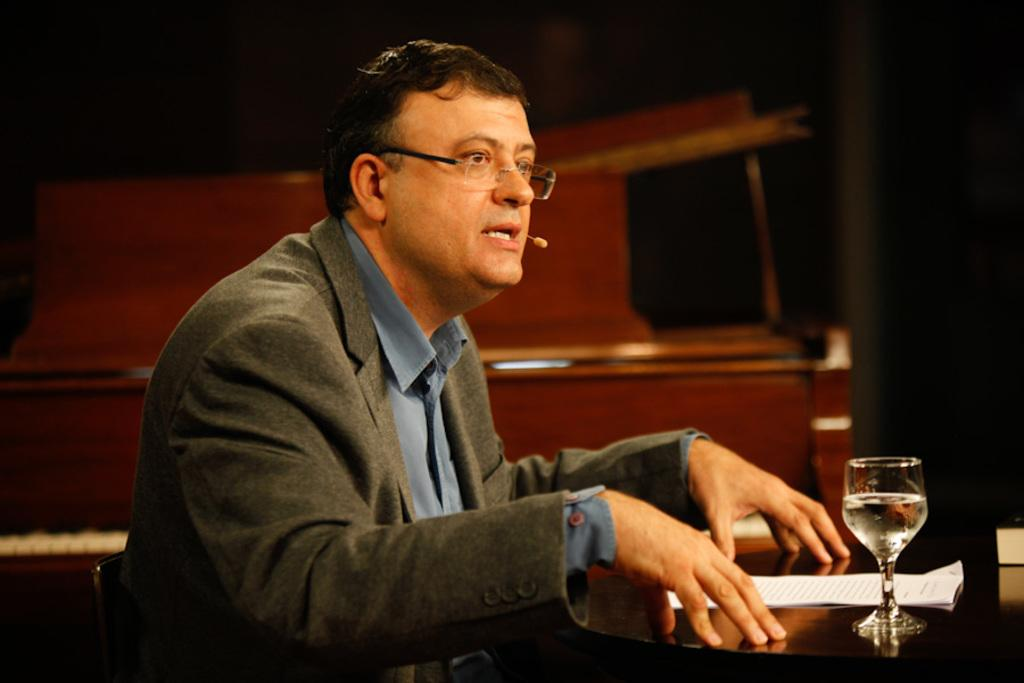Who is present in the image? There is a person in the image. What can be observed about the person's appearance? The person is wearing spectacles. What is the person's position in the image? The person is sitting on a chair. What is the chair's location in relation to the table? The chair is in front of a table. What objects are on the table? There is a glass and papers on the table. What type of leaf is blowing in the background of the image? There is no leaf present in the image, nor is there any indication of blowing in the background. 